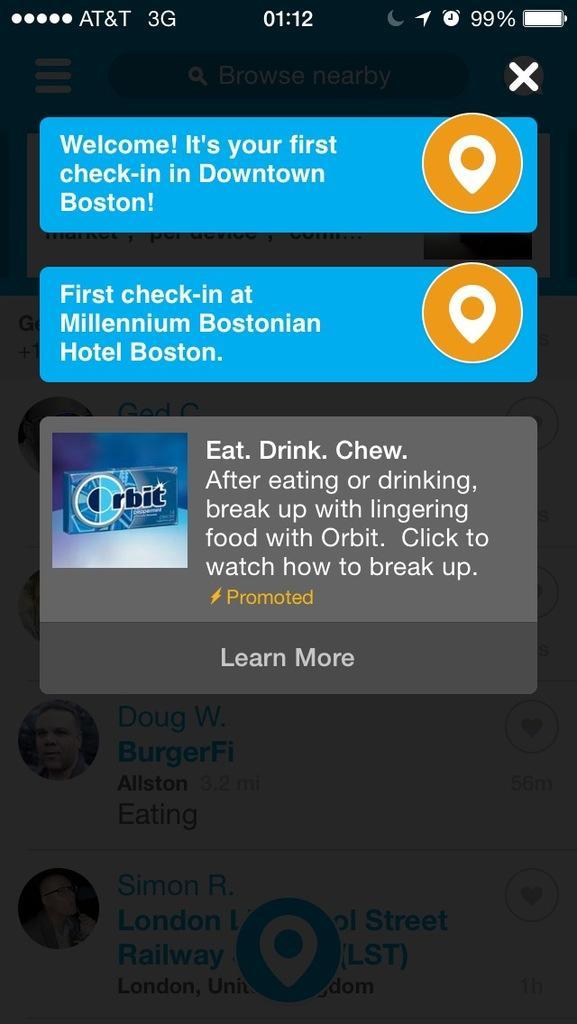Could you give a brief overview of what you see in this image? In this picture we can see a mobile screen,on this screen we can see some text. 